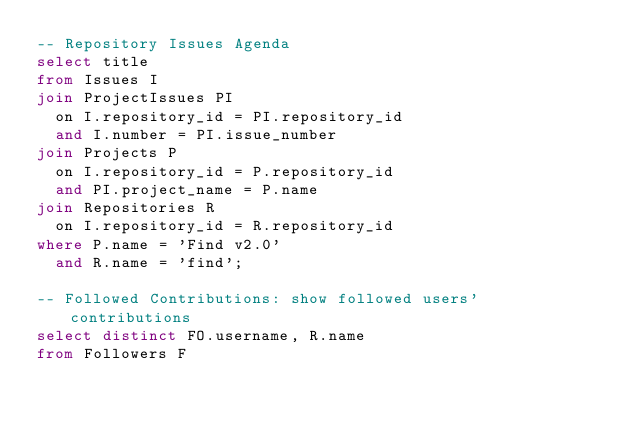<code> <loc_0><loc_0><loc_500><loc_500><_SQL_>-- Repository Issues Agenda
select title
from Issues I
join ProjectIssues PI
  on I.repository_id = PI.repository_id
  and I.number = PI.issue_number
join Projects P
  on I.repository_id = P.repository_id
  and PI.project_name = P.name
join Repositories R
  on I.repository_id = R.repository_id
where P.name = 'Find v2.0'
  and R.name = 'find';

-- Followed Contributions: show followed users' contributions
select distinct FO.username, R.name
from Followers F</code> 